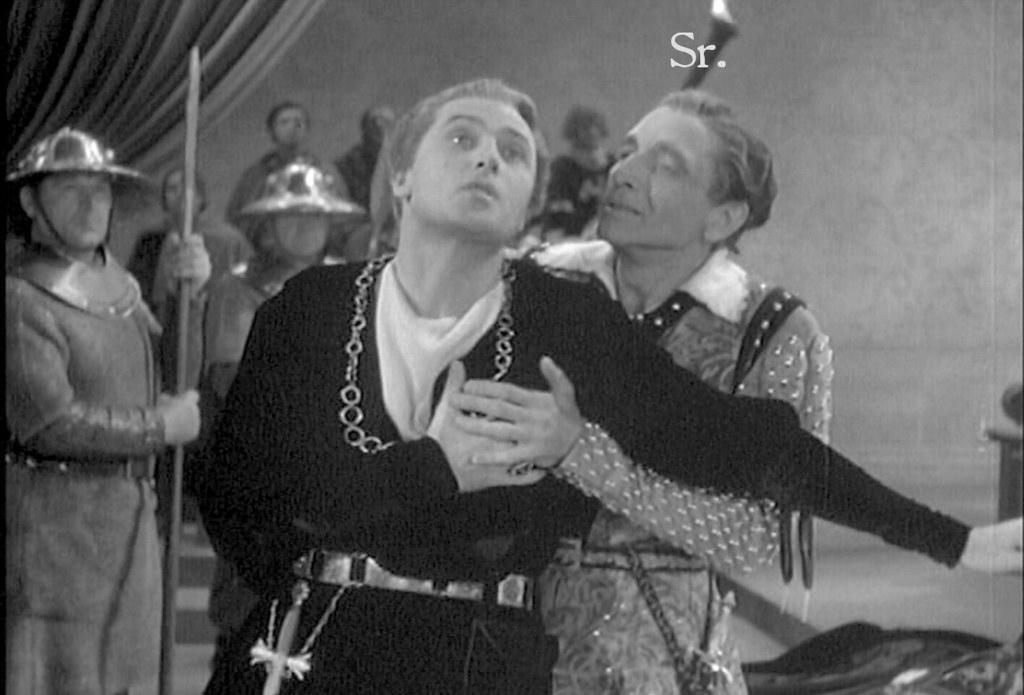How many people are visible in the image? There are two persons standing in the image. What is the relationship between the two persons? One person is holding another person. Can you describe the background of the image? There is a group of people standing in the background. Is there any additional information about the image itself? Yes, there is a watermark on the image. What type of desk can be seen in the image? There is no desk present in the image. How does the spark affect the interaction between the two persons? There is no spark present in the image, so it does not affect the interaction between the two persons. 